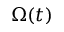Convert formula to latex. <formula><loc_0><loc_0><loc_500><loc_500>\Omega ( t )</formula> 